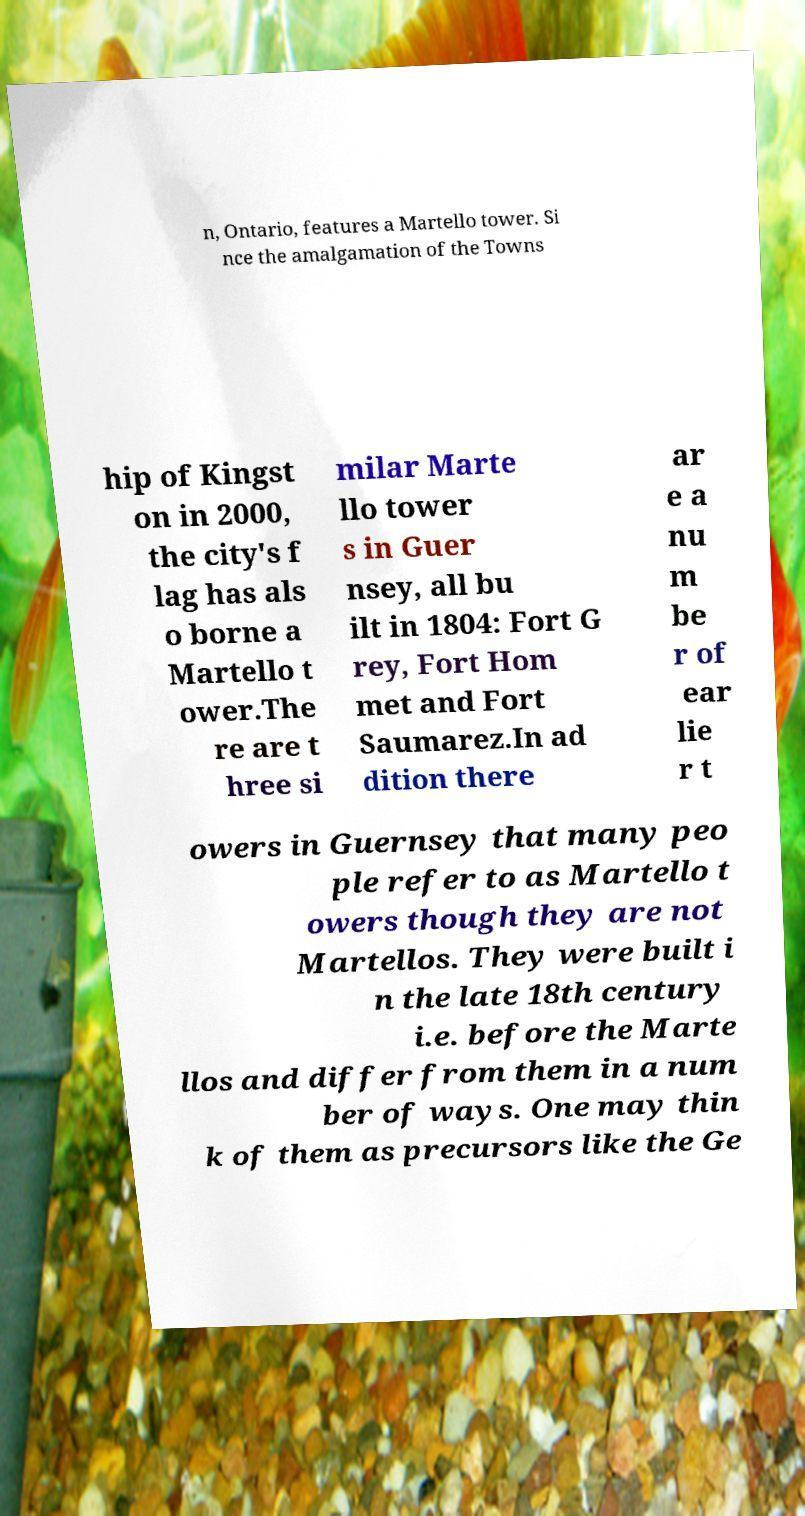Could you extract and type out the text from this image? n, Ontario, features a Martello tower. Si nce the amalgamation of the Towns hip of Kingst on in 2000, the city's f lag has als o borne a Martello t ower.The re are t hree si milar Marte llo tower s in Guer nsey, all bu ilt in 1804: Fort G rey, Fort Hom met and Fort Saumarez.In ad dition there ar e a nu m be r of ear lie r t owers in Guernsey that many peo ple refer to as Martello t owers though they are not Martellos. They were built i n the late 18th century i.e. before the Marte llos and differ from them in a num ber of ways. One may thin k of them as precursors like the Ge 